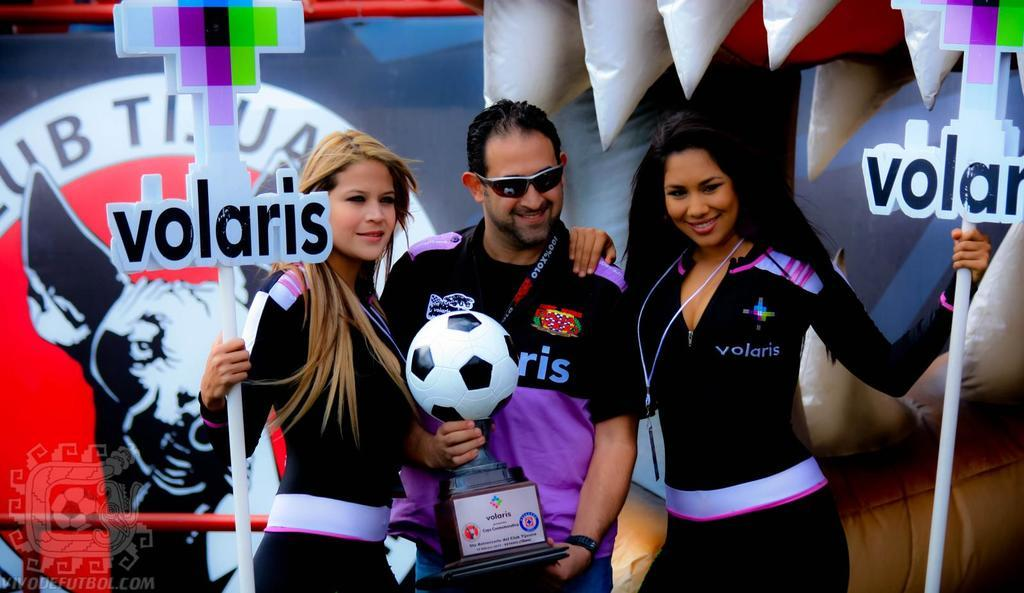<image>
Present a compact description of the photo's key features. Two women holding signs for Volaris stand next to a man holding a soccer ball. 